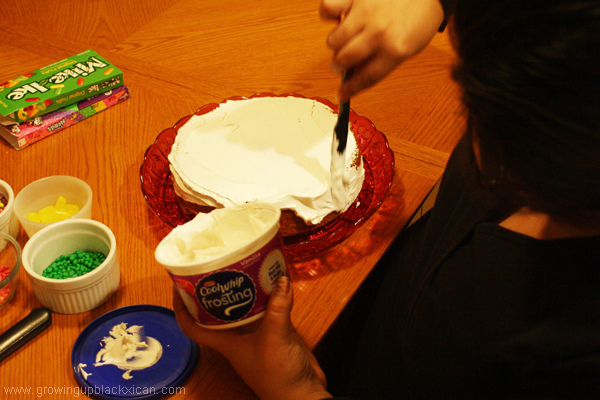Identify and read out the text in this image. www.growingupblackxican.com Cools chump frosTing Mike 